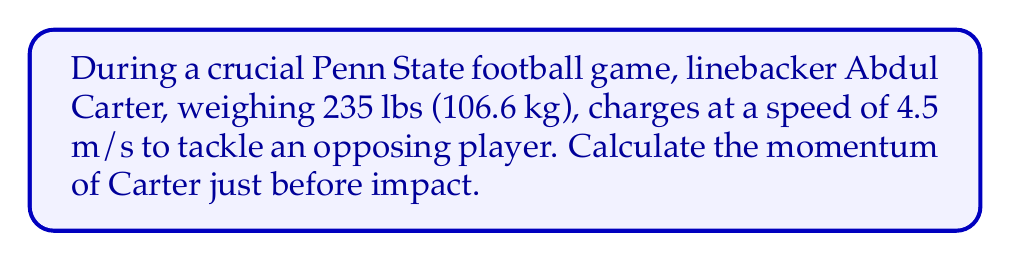Show me your answer to this math problem. To solve this problem, we'll use the formula for linear momentum:

$$p = mv$$

Where:
$p$ = momentum (kg⋅m/s)
$m$ = mass (kg)
$v$ = velocity (m/s)

Step 1: Identify the given values
- Mass (m) = 106.6 kg
- Velocity (v) = 4.5 m/s

Step 2: Substitute the values into the momentum formula
$$p = (106.6 \text{ kg})(4.5 \text{ m/s})$$

Step 3: Perform the multiplication
$$p = 479.7 \text{ kg⋅m/s}$$

Therefore, the momentum of Abdul Carter just before tackling the opposing player is 479.7 kg⋅m/s.
Answer: 479.7 kg⋅m/s 